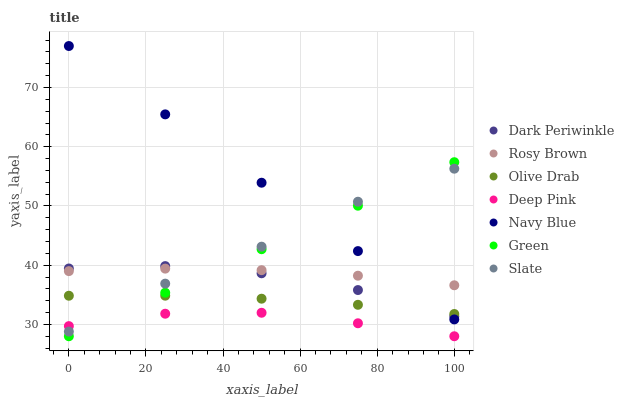Does Deep Pink have the minimum area under the curve?
Answer yes or no. Yes. Does Navy Blue have the maximum area under the curve?
Answer yes or no. Yes. Does Slate have the minimum area under the curve?
Answer yes or no. No. Does Slate have the maximum area under the curve?
Answer yes or no. No. Is Navy Blue the smoothest?
Answer yes or no. Yes. Is Slate the roughest?
Answer yes or no. Yes. Is Slate the smoothest?
Answer yes or no. No. Is Navy Blue the roughest?
Answer yes or no. No. Does Deep Pink have the lowest value?
Answer yes or no. Yes. Does Navy Blue have the lowest value?
Answer yes or no. No. Does Navy Blue have the highest value?
Answer yes or no. Yes. Does Slate have the highest value?
Answer yes or no. No. Is Deep Pink less than Rosy Brown?
Answer yes or no. Yes. Is Rosy Brown greater than Deep Pink?
Answer yes or no. Yes. Does Slate intersect Navy Blue?
Answer yes or no. Yes. Is Slate less than Navy Blue?
Answer yes or no. No. Is Slate greater than Navy Blue?
Answer yes or no. No. Does Deep Pink intersect Rosy Brown?
Answer yes or no. No. 